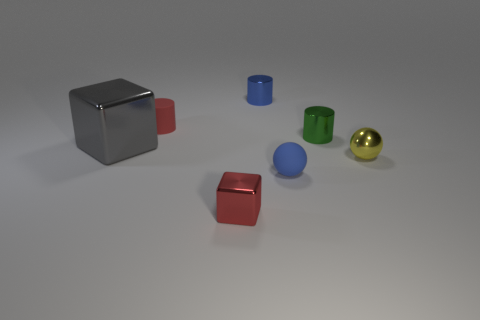There is a cube that is the same color as the tiny rubber cylinder; what size is it?
Make the answer very short. Small. There is a cylinder that is the same color as the small matte ball; what material is it?
Offer a very short reply. Metal. Do the object that is on the right side of the small green cylinder and the thing that is behind the small red cylinder have the same size?
Give a very brief answer. Yes. Is the number of small red metal blocks that are behind the tiny red block greater than the number of big gray blocks that are on the left side of the tiny yellow metal thing?
Your response must be concise. No. Are there any tiny red objects made of the same material as the yellow ball?
Ensure brevity in your answer.  Yes. Is the color of the matte cylinder the same as the large metal cube?
Offer a terse response. No. What is the material of the tiny object that is both to the left of the small blue matte ball and in front of the shiny ball?
Your response must be concise. Metal. The tiny metallic sphere has what color?
Make the answer very short. Yellow. What number of tiny green shiny objects have the same shape as the large gray object?
Provide a short and direct response. 0. Does the tiny green cylinder that is behind the small blue sphere have the same material as the red thing behind the gray thing?
Your response must be concise. No. 